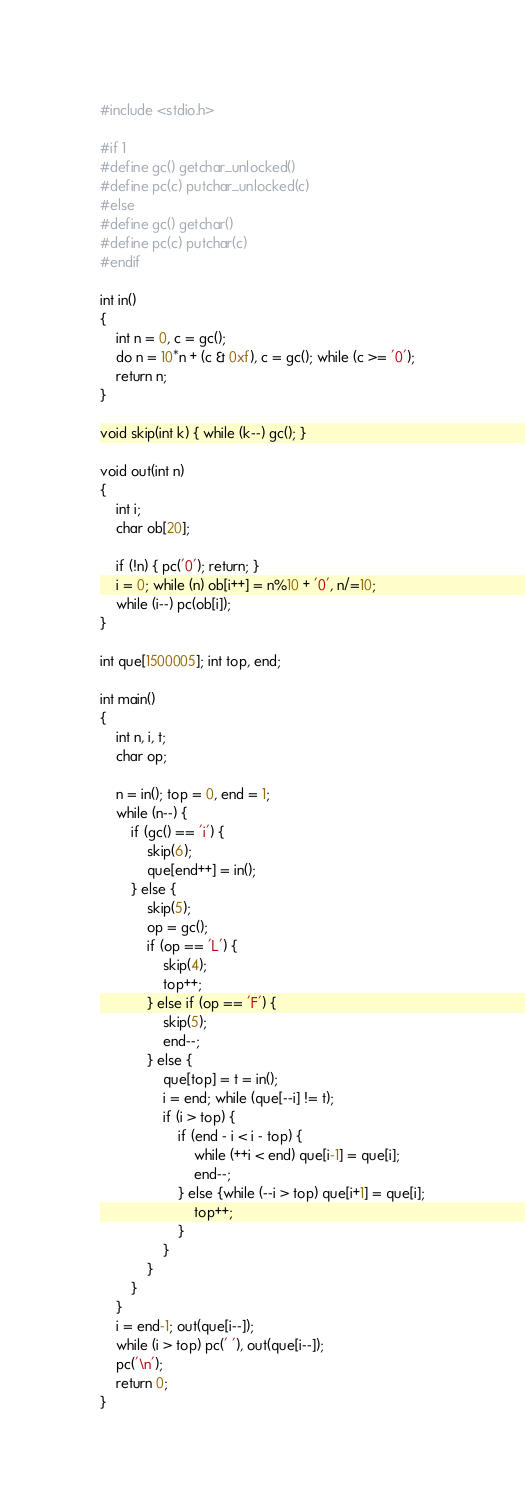<code> <loc_0><loc_0><loc_500><loc_500><_C_>#include <stdio.h>
 
#if 1
#define gc() getchar_unlocked()
#define pc(c) putchar_unlocked(c)
#else
#define gc() getchar()
#define pc(c) putchar(c)
#endif
 
int in()
{
	int n = 0, c = gc();
	do n = 10*n + (c & 0xf), c = gc(); while (c >= '0');
	return n;
}
 
void skip(int k) { while (k--) gc(); }
 
void out(int n)
{
	int i;
	char ob[20];
 
	if (!n) { pc('0'); return; }
	i = 0; while (n) ob[i++] = n%10 + '0', n/=10;
	while (i--) pc(ob[i]); 
}
 
int que[1500005]; int top, end;
 
int main()
{
	int n, i, t;
	char op;
 
	n = in(); top = 0, end = 1;
	while (n--) {
		if (gc() == 'i') {
			skip(6);
			que[end++] = in();
		} else {
			skip(5);
			op = gc();
			if (op == 'L') {
				skip(4);
				top++;
			} else if (op == 'F') {
				skip(5);
				end--;
			} else {
				que[top] = t = in();
				i = end; while (que[--i] != t);
				if (i > top) {
					if (end - i < i - top) {
						while (++i < end) que[i-1] = que[i];
						end--;
					} else {while (--i > top) que[i+1] = que[i];
						top++;
					}
				}
			}
		}
	}
	i = end-1; out(que[i--]);
	while (i > top) pc(' '), out(que[i--]);
	pc('\n');
	return 0;
}


</code> 